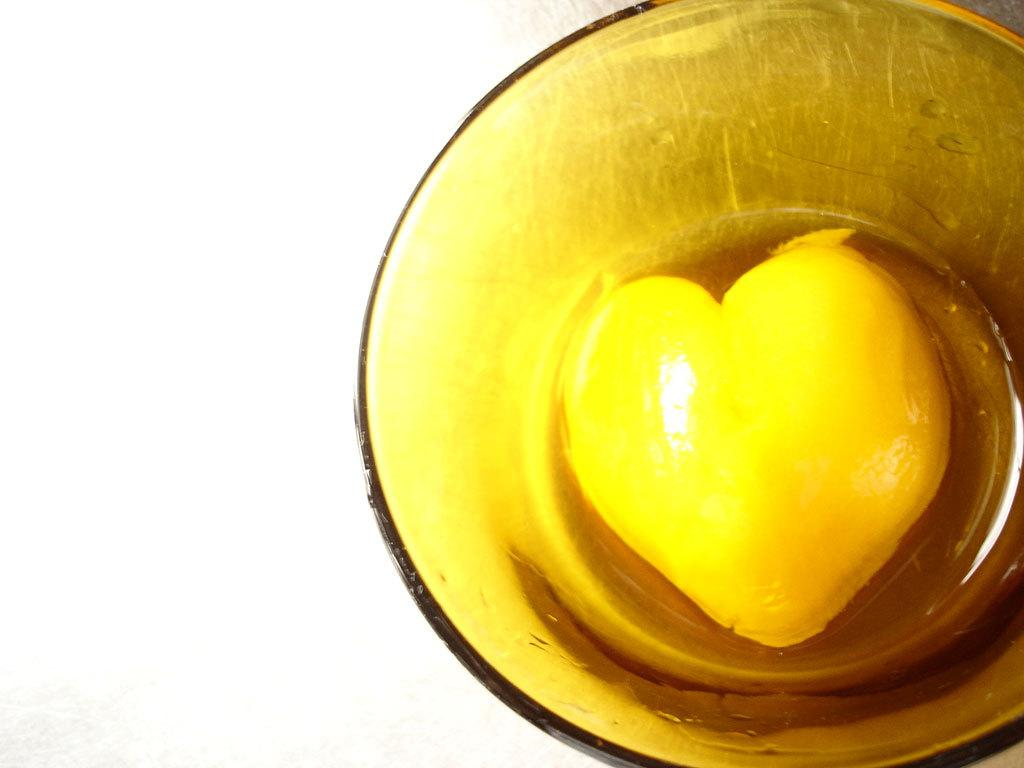What is in the bowl that is visible in the image? The bowl contains food. What can be inferred about the food in the bowl? The food is likely meant for consumption, as it is contained in a bowl. Where is the bowl located in the image? The bowl is placed on a surface. What statement is being made on the stage in the image? There is no stage or statement present in the image; it only features a bowl with food on a surface. 